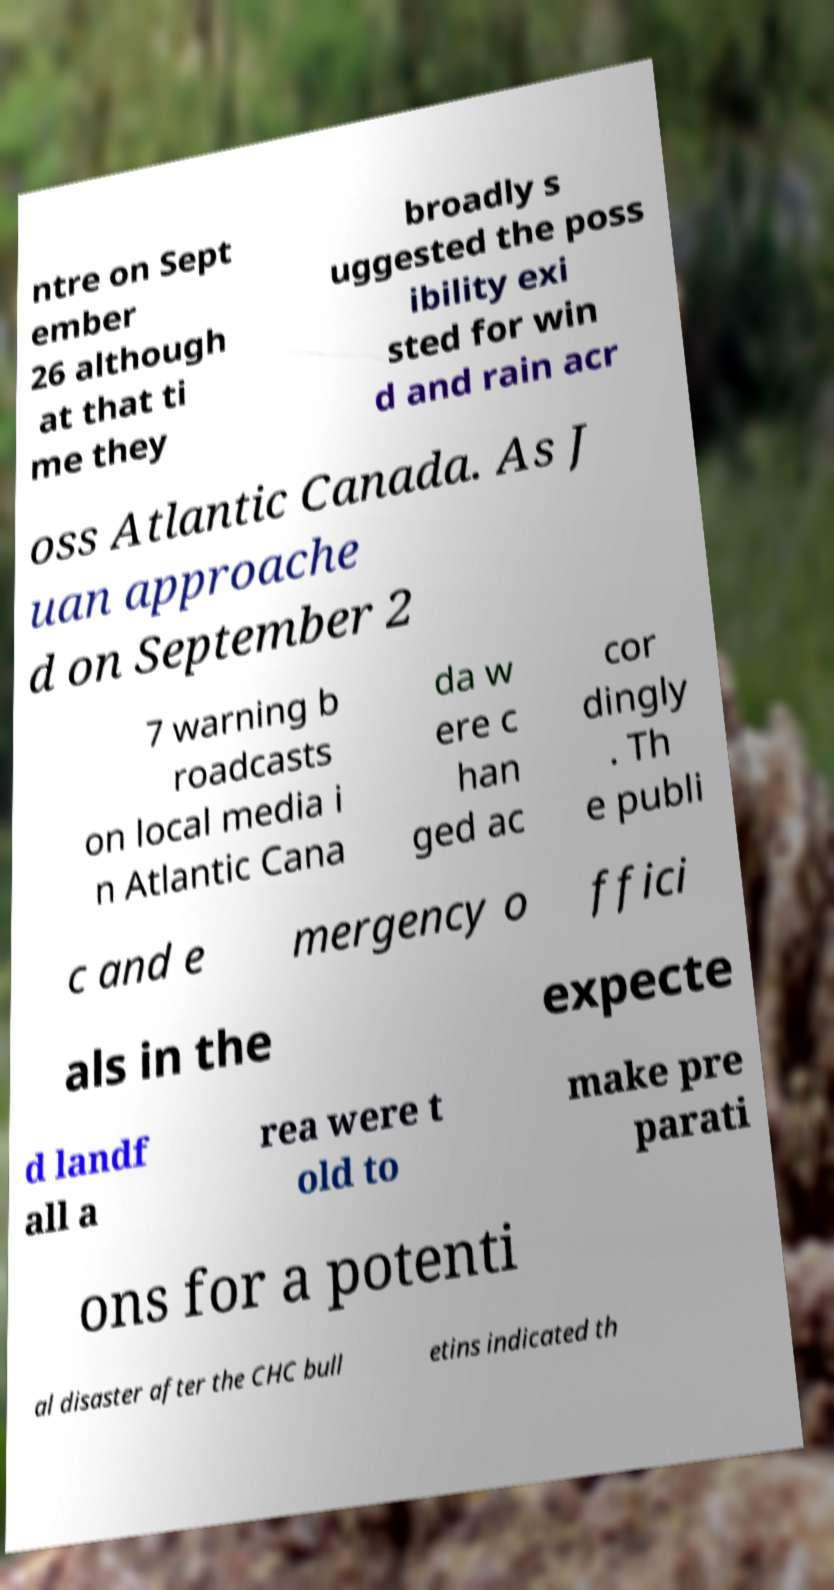Could you extract and type out the text from this image? ntre on Sept ember 26 although at that ti me they broadly s uggested the poss ibility exi sted for win d and rain acr oss Atlantic Canada. As J uan approache d on September 2 7 warning b roadcasts on local media i n Atlantic Cana da w ere c han ged ac cor dingly . Th e publi c and e mergency o ffici als in the expecte d landf all a rea were t old to make pre parati ons for a potenti al disaster after the CHC bull etins indicated th 